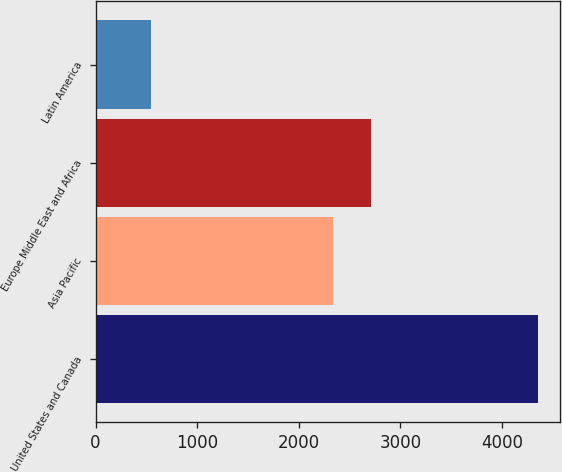Convert chart. <chart><loc_0><loc_0><loc_500><loc_500><bar_chart><fcel>United States and Canada<fcel>Asia Pacific<fcel>Europe Middle East and Africa<fcel>Latin America<nl><fcel>4350<fcel>2333<fcel>2713.7<fcel>543<nl></chart> 